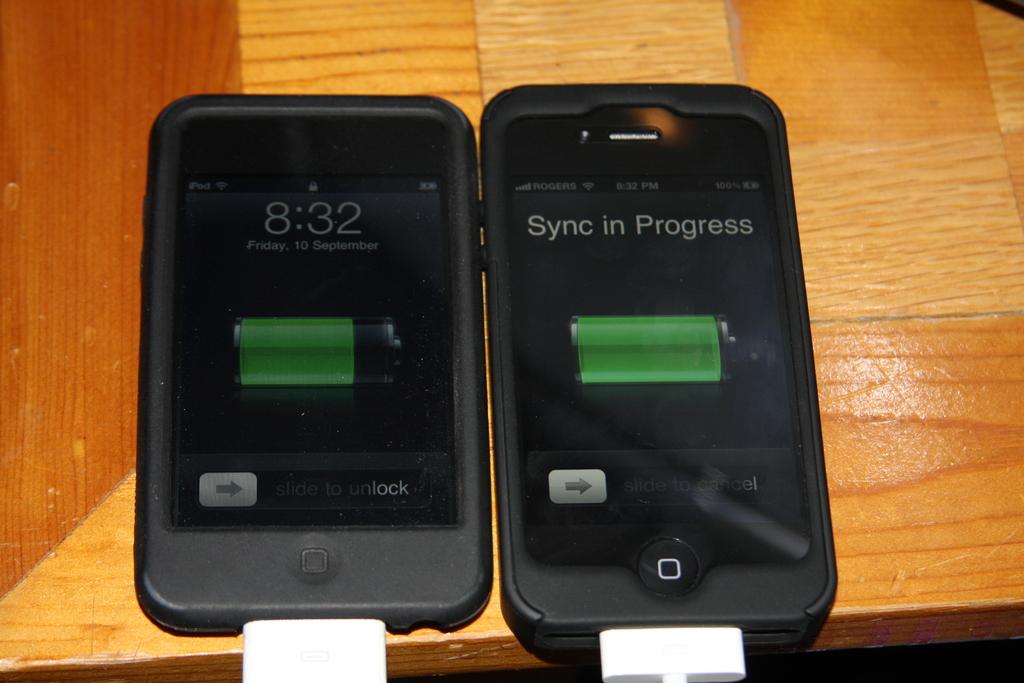What number is shown?
Ensure brevity in your answer.  8:32. What is in progress?
Give a very brief answer. Sync. 